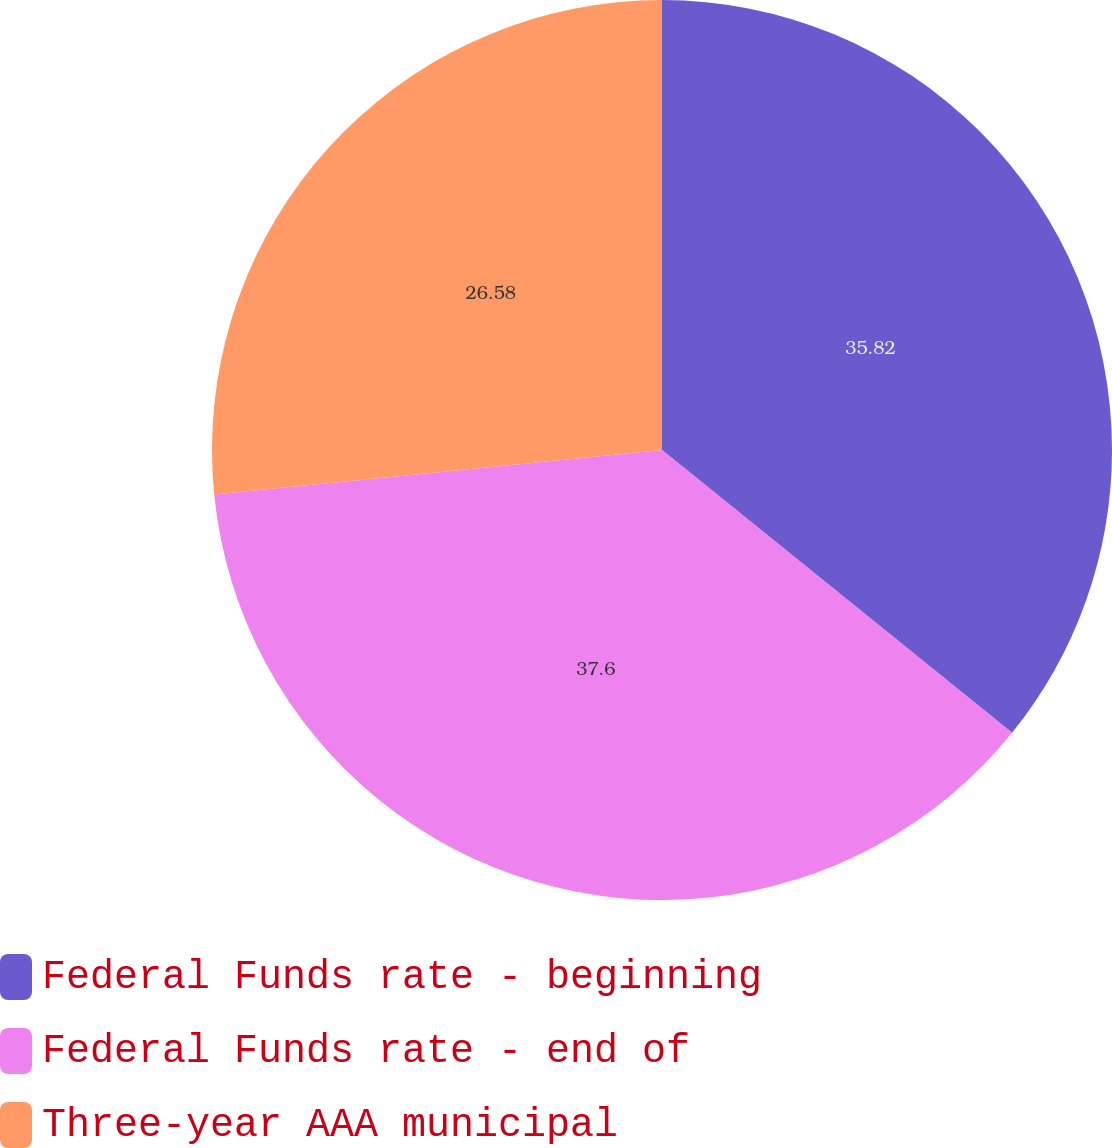Convert chart to OTSL. <chart><loc_0><loc_0><loc_500><loc_500><pie_chart><fcel>Federal Funds rate - beginning<fcel>Federal Funds rate - end of<fcel>Three-year AAA municipal<nl><fcel>35.82%<fcel>37.61%<fcel>26.58%<nl></chart> 